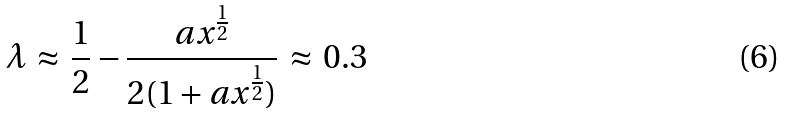<formula> <loc_0><loc_0><loc_500><loc_500>\lambda \, \approx \, \frac { 1 } { 2 } - \frac { a x ^ { \frac { 1 } { 2 } } } { 2 ( 1 + a x ^ { \frac { 1 } { 2 } } ) } \, \approx \, 0 . 3</formula> 